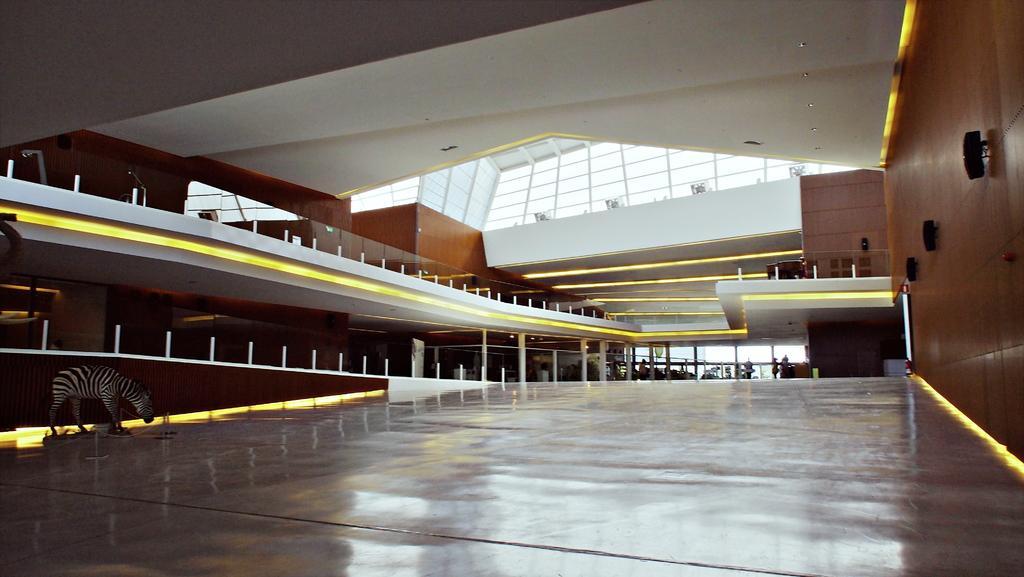Could you give a brief overview of what you see in this image? In this image I can see the floor, an animal which is white and black in color, the brown colored wall, few black colored objects to the wall, few white colored poles, the ceiling, few lights to the ceiling, few persons and few windows. 